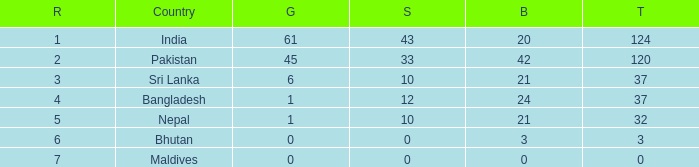How much Silver has a Rank of 7? 1.0. 